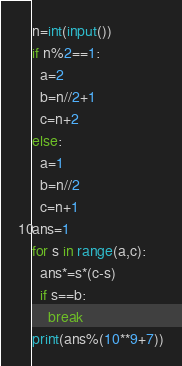Convert code to text. <code><loc_0><loc_0><loc_500><loc_500><_Python_>n=int(input())
if n%2==1:
  a=2
  b=n//2+1
  c=n+2
else:
  a=1
  b=n//2
  c=n+1
ans=1
for s in range(a,c):
  ans*=s*(c-s)
  if s==b:
    break
print(ans%(10**9+7))</code> 